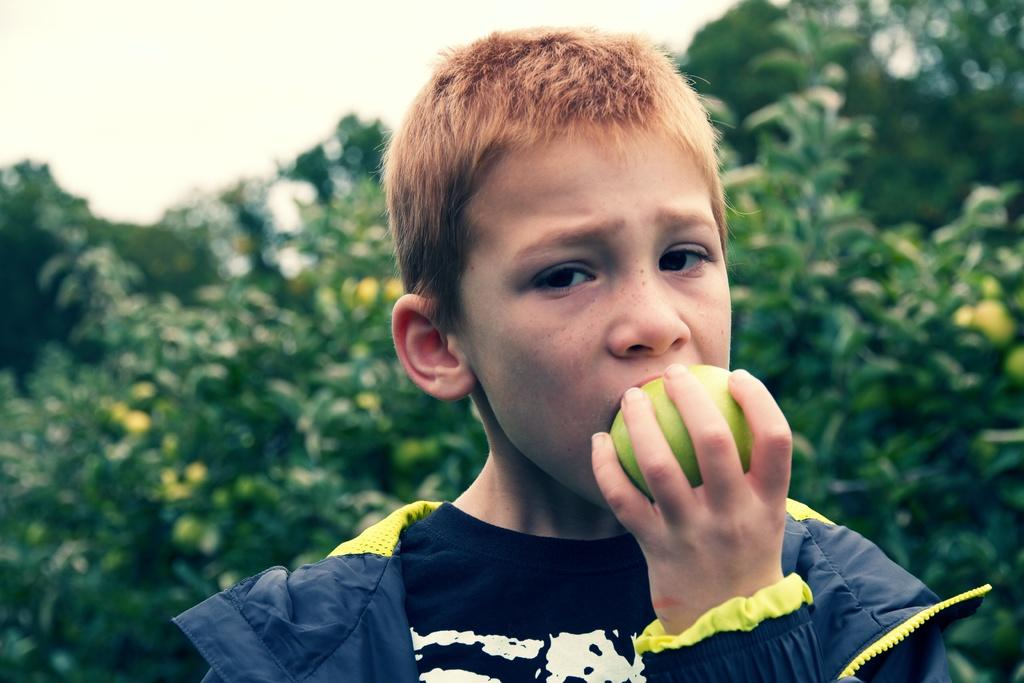What is the person holding in the image? The person is holding a green color fruit in the image. Can you describe the person's clothing? The person is wearing a dress with navy blue and yellow colors. What can be seen in the background of the image? There are many trees and the sky visible in the background of the image. What type of toy is the person testing in the image? There is no toy or testing activity present in the image. 